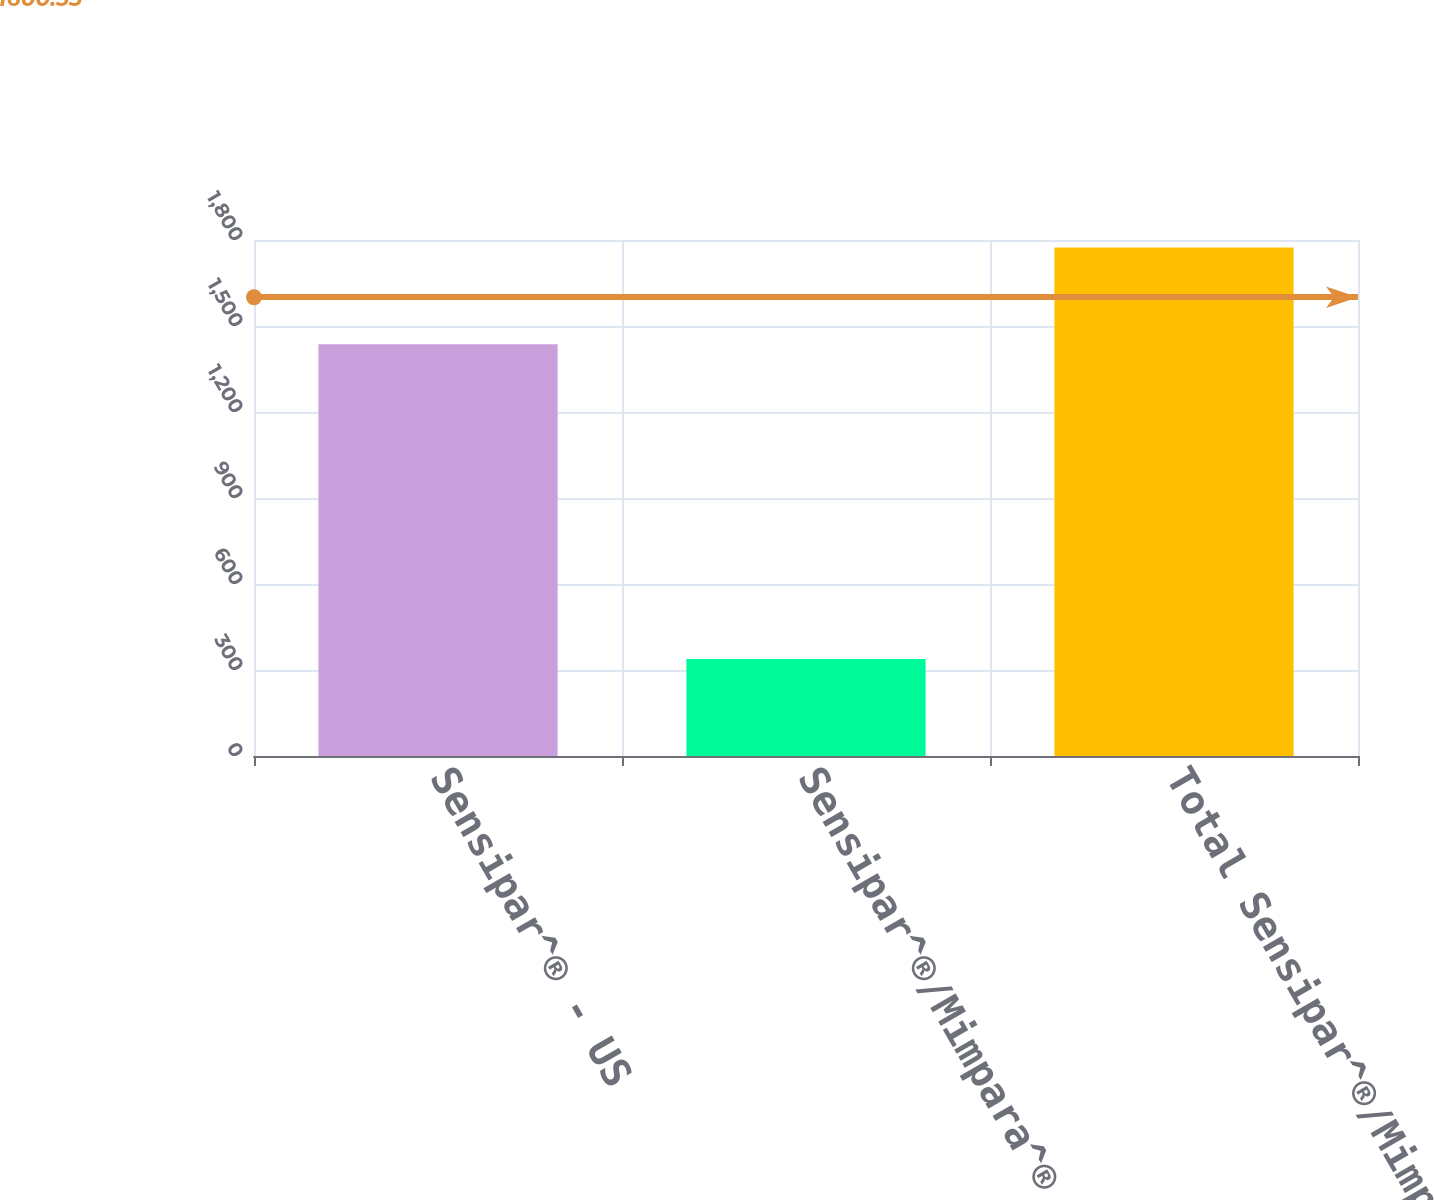Convert chart to OTSL. <chart><loc_0><loc_0><loc_500><loc_500><bar_chart><fcel>Sensipar^® - US<fcel>Sensipar^®/Mimpara^® - ROW<fcel>Total Sensipar^®/Mimpara ®<nl><fcel>1436<fcel>338<fcel>1774<nl></chart> 